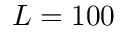Convert formula to latex. <formula><loc_0><loc_0><loc_500><loc_500>{ L = 1 0 0 }</formula> 